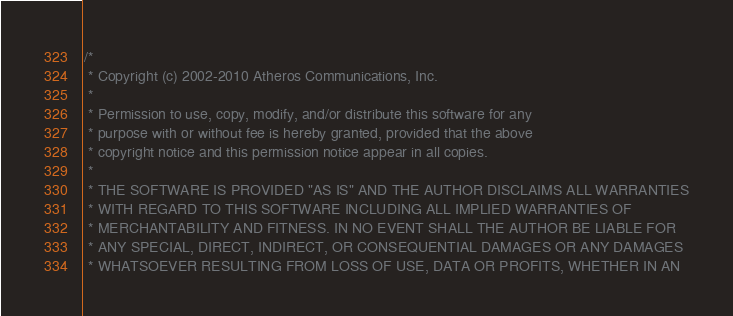Convert code to text. <code><loc_0><loc_0><loc_500><loc_500><_C_>/*
 * Copyright (c) 2002-2010 Atheros Communications, Inc.
 *
 * Permission to use, copy, modify, and/or distribute this software for any
 * purpose with or without fee is hereby granted, provided that the above
 * copyright notice and this permission notice appear in all copies.
 *
 * THE SOFTWARE IS PROVIDED "AS IS" AND THE AUTHOR DISCLAIMS ALL WARRANTIES
 * WITH REGARD TO THIS SOFTWARE INCLUDING ALL IMPLIED WARRANTIES OF
 * MERCHANTABILITY AND FITNESS. IN NO EVENT SHALL THE AUTHOR BE LIABLE FOR
 * ANY SPECIAL, DIRECT, INDIRECT, OR CONSEQUENTIAL DAMAGES OR ANY DAMAGES
 * WHATSOEVER RESULTING FROM LOSS OF USE, DATA OR PROFITS, WHETHER IN AN</code> 